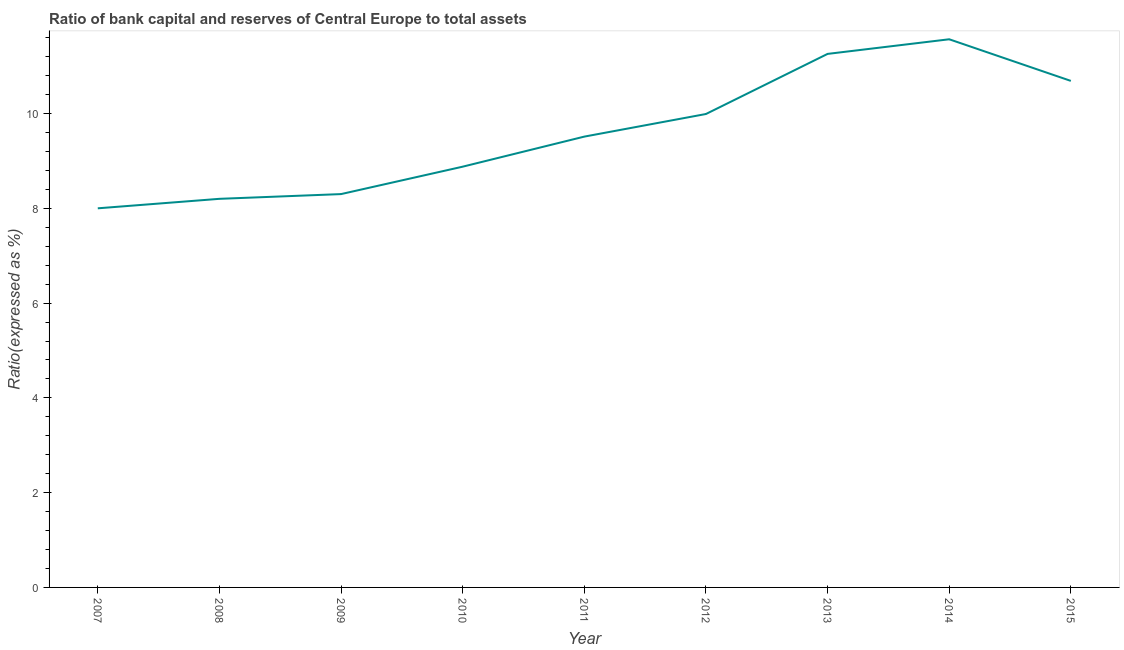What is the bank capital to assets ratio in 2010?
Provide a succinct answer. 8.88. Across all years, what is the maximum bank capital to assets ratio?
Offer a terse response. 11.57. In which year was the bank capital to assets ratio maximum?
Give a very brief answer. 2014. What is the sum of the bank capital to assets ratio?
Provide a succinct answer. 86.4. What is the difference between the bank capital to assets ratio in 2007 and 2012?
Make the answer very short. -1.99. What is the average bank capital to assets ratio per year?
Your answer should be very brief. 9.6. What is the median bank capital to assets ratio?
Ensure brevity in your answer.  9.51. In how many years, is the bank capital to assets ratio greater than 0.4 %?
Offer a terse response. 9. What is the ratio of the bank capital to assets ratio in 2010 to that in 2015?
Your answer should be very brief. 0.83. Is the bank capital to assets ratio in 2007 less than that in 2011?
Give a very brief answer. Yes. Is the difference between the bank capital to assets ratio in 2011 and 2013 greater than the difference between any two years?
Your answer should be compact. No. What is the difference between the highest and the second highest bank capital to assets ratio?
Your answer should be compact. 0.31. What is the difference between the highest and the lowest bank capital to assets ratio?
Your answer should be compact. 3.57. In how many years, is the bank capital to assets ratio greater than the average bank capital to assets ratio taken over all years?
Give a very brief answer. 4. Does the bank capital to assets ratio monotonically increase over the years?
Your response must be concise. No. What is the difference between two consecutive major ticks on the Y-axis?
Your answer should be very brief. 2. Does the graph contain any zero values?
Ensure brevity in your answer.  No. Does the graph contain grids?
Your answer should be very brief. No. What is the title of the graph?
Offer a very short reply. Ratio of bank capital and reserves of Central Europe to total assets. What is the label or title of the Y-axis?
Make the answer very short. Ratio(expressed as %). What is the Ratio(expressed as %) of 2010?
Ensure brevity in your answer.  8.88. What is the Ratio(expressed as %) of 2011?
Your response must be concise. 9.51. What is the Ratio(expressed as %) in 2012?
Make the answer very short. 9.99. What is the Ratio(expressed as %) in 2013?
Your response must be concise. 11.26. What is the Ratio(expressed as %) in 2014?
Offer a terse response. 11.57. What is the Ratio(expressed as %) of 2015?
Offer a very short reply. 10.69. What is the difference between the Ratio(expressed as %) in 2007 and 2008?
Provide a short and direct response. -0.2. What is the difference between the Ratio(expressed as %) in 2007 and 2010?
Provide a short and direct response. -0.88. What is the difference between the Ratio(expressed as %) in 2007 and 2011?
Keep it short and to the point. -1.51. What is the difference between the Ratio(expressed as %) in 2007 and 2012?
Provide a succinct answer. -1.99. What is the difference between the Ratio(expressed as %) in 2007 and 2013?
Ensure brevity in your answer.  -3.26. What is the difference between the Ratio(expressed as %) in 2007 and 2014?
Provide a succinct answer. -3.57. What is the difference between the Ratio(expressed as %) in 2007 and 2015?
Ensure brevity in your answer.  -2.69. What is the difference between the Ratio(expressed as %) in 2008 and 2009?
Offer a terse response. -0.1. What is the difference between the Ratio(expressed as %) in 2008 and 2010?
Offer a very short reply. -0.68. What is the difference between the Ratio(expressed as %) in 2008 and 2011?
Ensure brevity in your answer.  -1.31. What is the difference between the Ratio(expressed as %) in 2008 and 2012?
Offer a terse response. -1.79. What is the difference between the Ratio(expressed as %) in 2008 and 2013?
Offer a very short reply. -3.06. What is the difference between the Ratio(expressed as %) in 2008 and 2014?
Your response must be concise. -3.37. What is the difference between the Ratio(expressed as %) in 2008 and 2015?
Offer a very short reply. -2.49. What is the difference between the Ratio(expressed as %) in 2009 and 2010?
Make the answer very short. -0.58. What is the difference between the Ratio(expressed as %) in 2009 and 2011?
Your answer should be compact. -1.21. What is the difference between the Ratio(expressed as %) in 2009 and 2012?
Provide a succinct answer. -1.69. What is the difference between the Ratio(expressed as %) in 2009 and 2013?
Provide a succinct answer. -2.96. What is the difference between the Ratio(expressed as %) in 2009 and 2014?
Ensure brevity in your answer.  -3.27. What is the difference between the Ratio(expressed as %) in 2009 and 2015?
Keep it short and to the point. -2.39. What is the difference between the Ratio(expressed as %) in 2010 and 2011?
Give a very brief answer. -0.63. What is the difference between the Ratio(expressed as %) in 2010 and 2012?
Offer a terse response. -1.11. What is the difference between the Ratio(expressed as %) in 2010 and 2013?
Your response must be concise. -2.38. What is the difference between the Ratio(expressed as %) in 2010 and 2014?
Your answer should be compact. -2.69. What is the difference between the Ratio(expressed as %) in 2010 and 2015?
Your answer should be compact. -1.81. What is the difference between the Ratio(expressed as %) in 2011 and 2012?
Offer a terse response. -0.48. What is the difference between the Ratio(expressed as %) in 2011 and 2013?
Your answer should be very brief. -1.75. What is the difference between the Ratio(expressed as %) in 2011 and 2014?
Give a very brief answer. -2.05. What is the difference between the Ratio(expressed as %) in 2011 and 2015?
Your answer should be compact. -1.18. What is the difference between the Ratio(expressed as %) in 2012 and 2013?
Offer a terse response. -1.27. What is the difference between the Ratio(expressed as %) in 2012 and 2014?
Provide a short and direct response. -1.58. What is the difference between the Ratio(expressed as %) in 2012 and 2015?
Offer a terse response. -0.7. What is the difference between the Ratio(expressed as %) in 2013 and 2014?
Keep it short and to the point. -0.31. What is the difference between the Ratio(expressed as %) in 2013 and 2015?
Offer a very short reply. 0.57. What is the difference between the Ratio(expressed as %) in 2014 and 2015?
Your response must be concise. 0.88. What is the ratio of the Ratio(expressed as %) in 2007 to that in 2008?
Offer a very short reply. 0.98. What is the ratio of the Ratio(expressed as %) in 2007 to that in 2010?
Provide a succinct answer. 0.9. What is the ratio of the Ratio(expressed as %) in 2007 to that in 2011?
Make the answer very short. 0.84. What is the ratio of the Ratio(expressed as %) in 2007 to that in 2012?
Your answer should be very brief. 0.8. What is the ratio of the Ratio(expressed as %) in 2007 to that in 2013?
Your response must be concise. 0.71. What is the ratio of the Ratio(expressed as %) in 2007 to that in 2014?
Your response must be concise. 0.69. What is the ratio of the Ratio(expressed as %) in 2007 to that in 2015?
Provide a short and direct response. 0.75. What is the ratio of the Ratio(expressed as %) in 2008 to that in 2010?
Ensure brevity in your answer.  0.92. What is the ratio of the Ratio(expressed as %) in 2008 to that in 2011?
Your response must be concise. 0.86. What is the ratio of the Ratio(expressed as %) in 2008 to that in 2012?
Give a very brief answer. 0.82. What is the ratio of the Ratio(expressed as %) in 2008 to that in 2013?
Provide a short and direct response. 0.73. What is the ratio of the Ratio(expressed as %) in 2008 to that in 2014?
Offer a terse response. 0.71. What is the ratio of the Ratio(expressed as %) in 2008 to that in 2015?
Give a very brief answer. 0.77. What is the ratio of the Ratio(expressed as %) in 2009 to that in 2010?
Make the answer very short. 0.94. What is the ratio of the Ratio(expressed as %) in 2009 to that in 2011?
Ensure brevity in your answer.  0.87. What is the ratio of the Ratio(expressed as %) in 2009 to that in 2012?
Provide a short and direct response. 0.83. What is the ratio of the Ratio(expressed as %) in 2009 to that in 2013?
Your answer should be very brief. 0.74. What is the ratio of the Ratio(expressed as %) in 2009 to that in 2014?
Provide a short and direct response. 0.72. What is the ratio of the Ratio(expressed as %) in 2009 to that in 2015?
Give a very brief answer. 0.78. What is the ratio of the Ratio(expressed as %) in 2010 to that in 2011?
Give a very brief answer. 0.93. What is the ratio of the Ratio(expressed as %) in 2010 to that in 2012?
Your response must be concise. 0.89. What is the ratio of the Ratio(expressed as %) in 2010 to that in 2013?
Give a very brief answer. 0.79. What is the ratio of the Ratio(expressed as %) in 2010 to that in 2014?
Your answer should be very brief. 0.77. What is the ratio of the Ratio(expressed as %) in 2010 to that in 2015?
Keep it short and to the point. 0.83. What is the ratio of the Ratio(expressed as %) in 2011 to that in 2013?
Ensure brevity in your answer.  0.84. What is the ratio of the Ratio(expressed as %) in 2011 to that in 2014?
Your answer should be very brief. 0.82. What is the ratio of the Ratio(expressed as %) in 2011 to that in 2015?
Your answer should be very brief. 0.89. What is the ratio of the Ratio(expressed as %) in 2012 to that in 2013?
Make the answer very short. 0.89. What is the ratio of the Ratio(expressed as %) in 2012 to that in 2014?
Your answer should be very brief. 0.86. What is the ratio of the Ratio(expressed as %) in 2012 to that in 2015?
Your answer should be very brief. 0.94. What is the ratio of the Ratio(expressed as %) in 2013 to that in 2014?
Give a very brief answer. 0.97. What is the ratio of the Ratio(expressed as %) in 2013 to that in 2015?
Provide a short and direct response. 1.05. What is the ratio of the Ratio(expressed as %) in 2014 to that in 2015?
Provide a short and direct response. 1.08. 